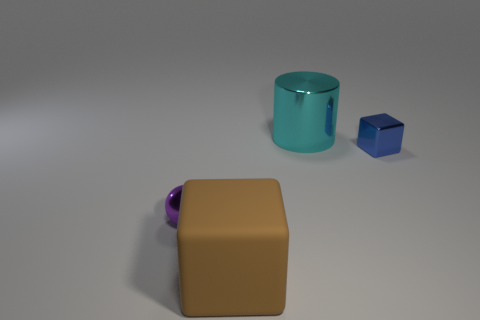There is a thing that is in front of the metallic sphere; what is its shape?
Make the answer very short. Cube. The small shiny block is what color?
Provide a short and direct response. Blue. Is the size of the cyan cylinder the same as the metallic object right of the cyan thing?
Keep it short and to the point. No. How many rubber objects are either tiny things or blue blocks?
Keep it short and to the point. 0. Is there any other thing that has the same material as the small block?
Give a very brief answer. Yes. Is the color of the metal block the same as the tiny thing to the left of the large cyan shiny object?
Offer a terse response. No. There is a blue metal object; what shape is it?
Provide a succinct answer. Cube. There is a cube that is behind the tiny shiny sphere that is left of the big object that is in front of the tiny purple sphere; what is its size?
Keep it short and to the point. Small. What number of other things are there of the same shape as the big cyan shiny object?
Make the answer very short. 0. Is the shape of the large object in front of the large cyan object the same as the big object behind the purple thing?
Ensure brevity in your answer.  No. 